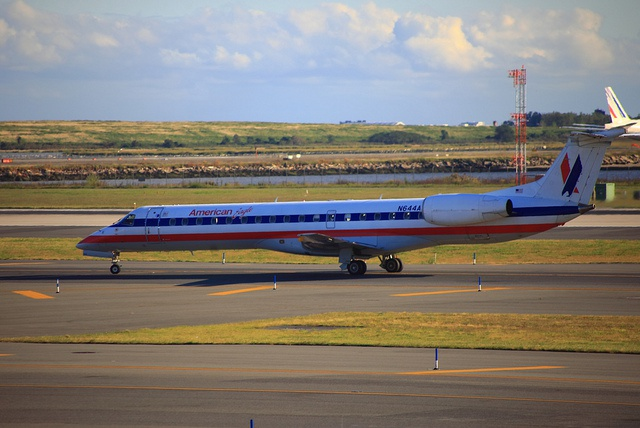Describe the objects in this image and their specific colors. I can see airplane in darkgray, gray, black, maroon, and navy tones and airplane in darkgray, beige, khaki, and pink tones in this image. 